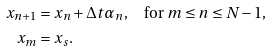<formula> <loc_0><loc_0><loc_500><loc_500>x _ { n + 1 } & = x _ { n } + \Delta t \alpha _ { n } , \quad \text {for } m \leq n \leq N - 1 , \\ x _ { m } & = x _ { s } .</formula> 